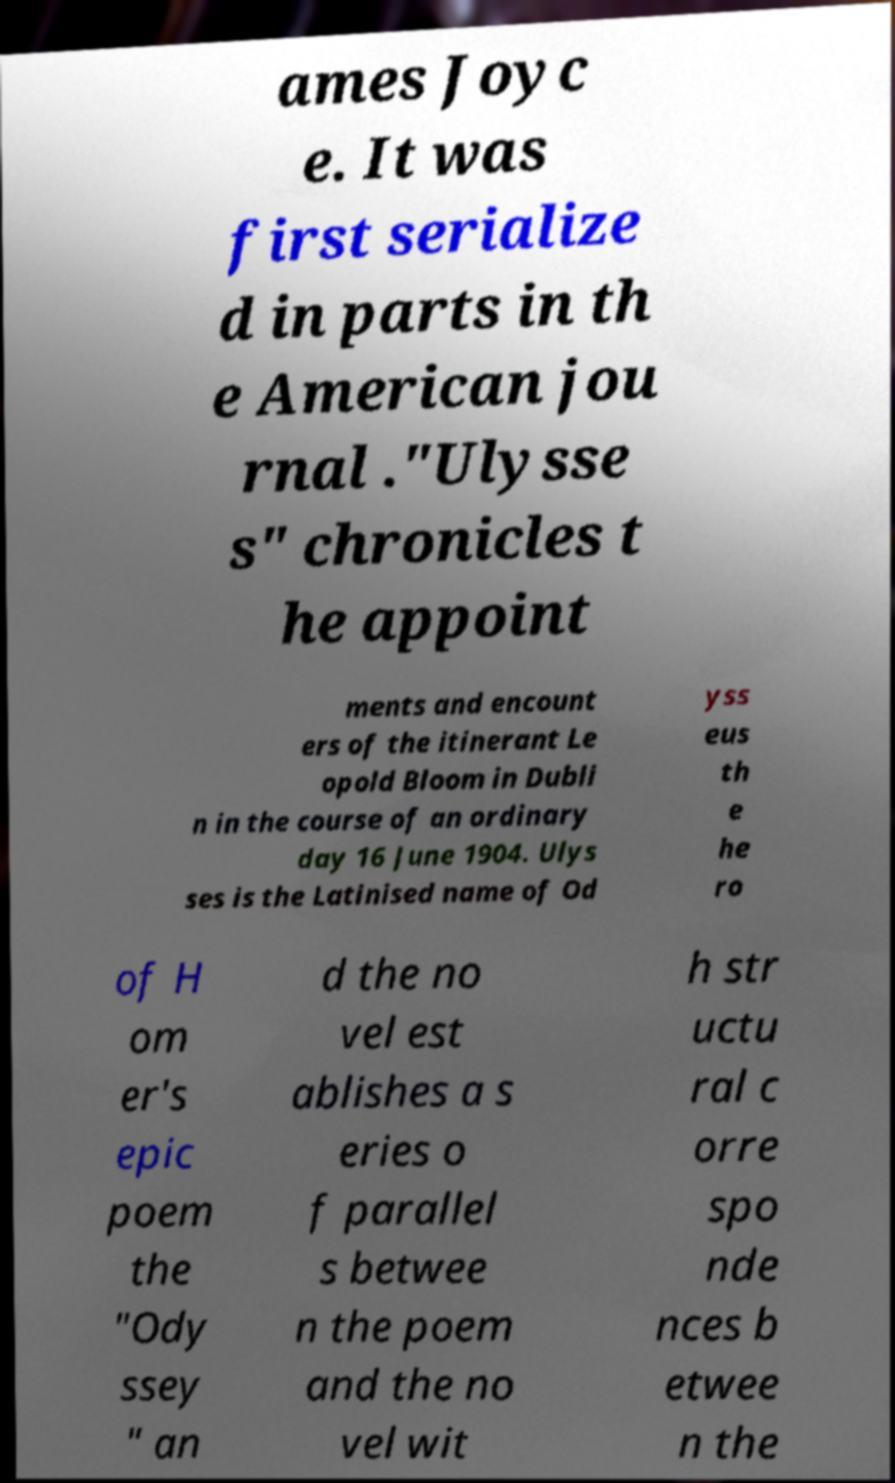There's text embedded in this image that I need extracted. Can you transcribe it verbatim? ames Joyc e. It was first serialize d in parts in th e American jou rnal ."Ulysse s" chronicles t he appoint ments and encount ers of the itinerant Le opold Bloom in Dubli n in the course of an ordinary day 16 June 1904. Ulys ses is the Latinised name of Od yss eus th e he ro of H om er's epic poem the "Ody ssey " an d the no vel est ablishes a s eries o f parallel s betwee n the poem and the no vel wit h str uctu ral c orre spo nde nces b etwee n the 